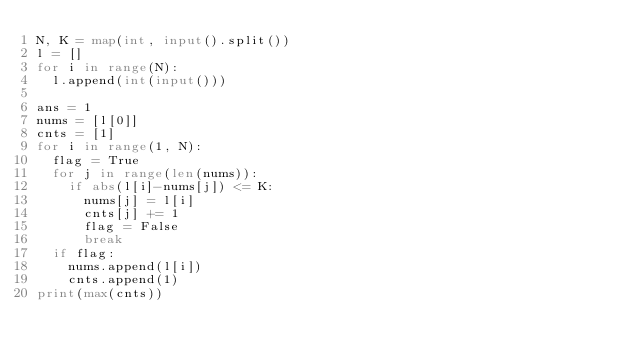<code> <loc_0><loc_0><loc_500><loc_500><_Python_>N, K = map(int, input().split())
l = []
for i in range(N):
  l.append(int(input()))
  
ans = 1
nums = [l[0]]
cnts = [1]
for i in range(1, N):
  flag = True
  for j in range(len(nums)):
    if abs(l[i]-nums[j]) <= K:
      nums[j] = l[i]
      cnts[j] += 1
      flag = False
      break
  if flag:
    nums.append(l[i])
    cnts.append(1)
print(max(cnts))</code> 